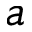Convert formula to latex. <formula><loc_0><loc_0><loc_500><loc_500>a</formula> 